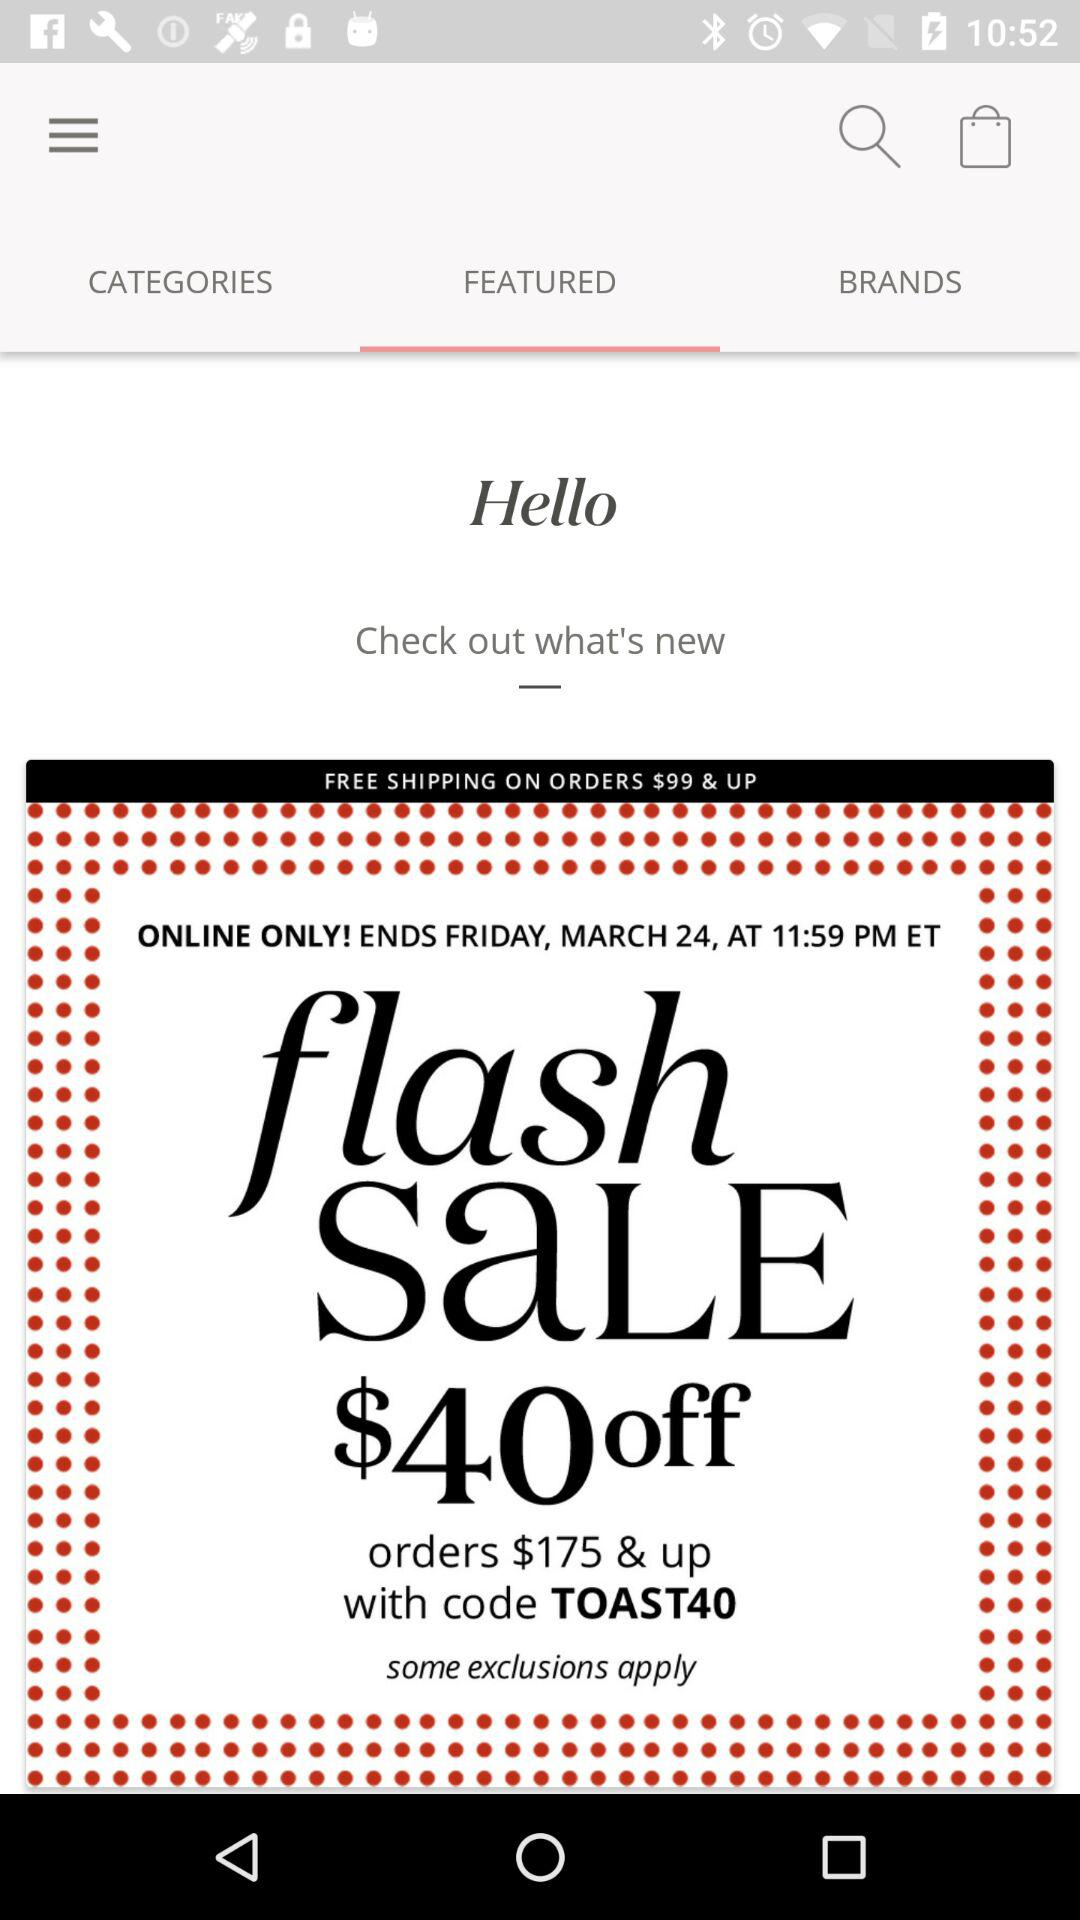Which is the selected tab? The selected tab is "FEATURED". 